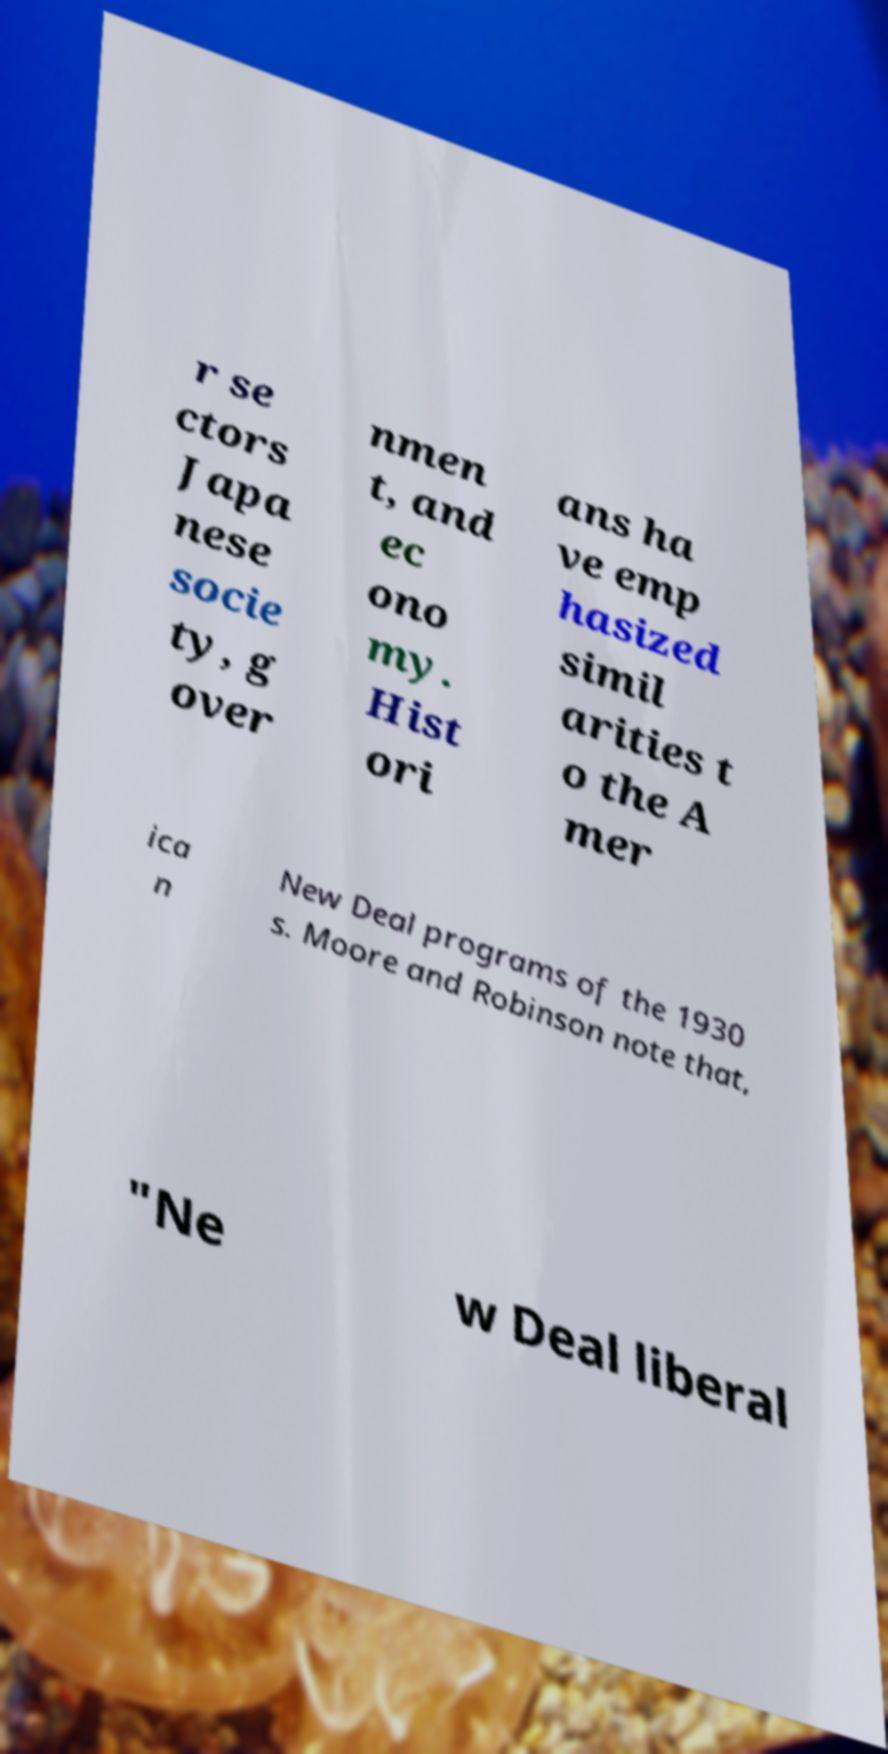Can you read and provide the text displayed in the image?This photo seems to have some interesting text. Can you extract and type it out for me? r se ctors Japa nese socie ty, g over nmen t, and ec ono my. Hist ori ans ha ve emp hasized simil arities t o the A mer ica n New Deal programs of the 1930 s. Moore and Robinson note that, "Ne w Deal liberal 